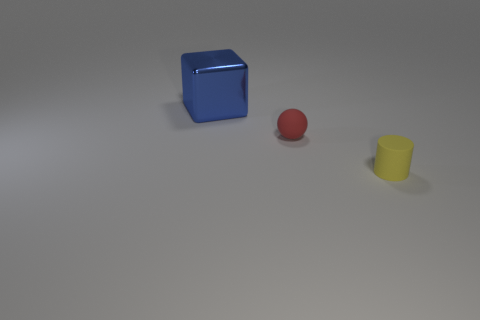Subtract 1 blocks. How many blocks are left? 0 Add 2 yellow things. How many objects exist? 5 Subtract all cylinders. How many objects are left? 2 Subtract all big gray objects. Subtract all yellow matte cylinders. How many objects are left? 2 Add 2 red rubber spheres. How many red rubber spheres are left? 3 Add 2 big gray shiny cylinders. How many big gray shiny cylinders exist? 2 Subtract 0 green spheres. How many objects are left? 3 Subtract all purple balls. Subtract all red cylinders. How many balls are left? 1 